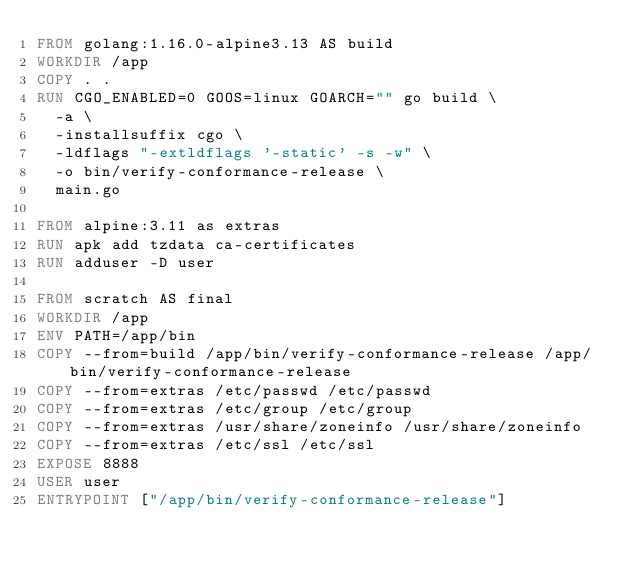Convert code to text. <code><loc_0><loc_0><loc_500><loc_500><_Dockerfile_>FROM golang:1.16.0-alpine3.13 AS build
WORKDIR /app
COPY . .
RUN CGO_ENABLED=0 GOOS=linux GOARCH="" go build \
  -a \
  -installsuffix cgo \
  -ldflags "-extldflags '-static' -s -w" \
  -o bin/verify-conformance-release \
  main.go

FROM alpine:3.11 as extras
RUN apk add tzdata ca-certificates
RUN adduser -D user

FROM scratch AS final
WORKDIR /app
ENV PATH=/app/bin
COPY --from=build /app/bin/verify-conformance-release /app/bin/verify-conformance-release
COPY --from=extras /etc/passwd /etc/passwd
COPY --from=extras /etc/group /etc/group
COPY --from=extras /usr/share/zoneinfo /usr/share/zoneinfo
COPY --from=extras /etc/ssl /etc/ssl
EXPOSE 8888
USER user
ENTRYPOINT ["/app/bin/verify-conformance-release"]
</code> 